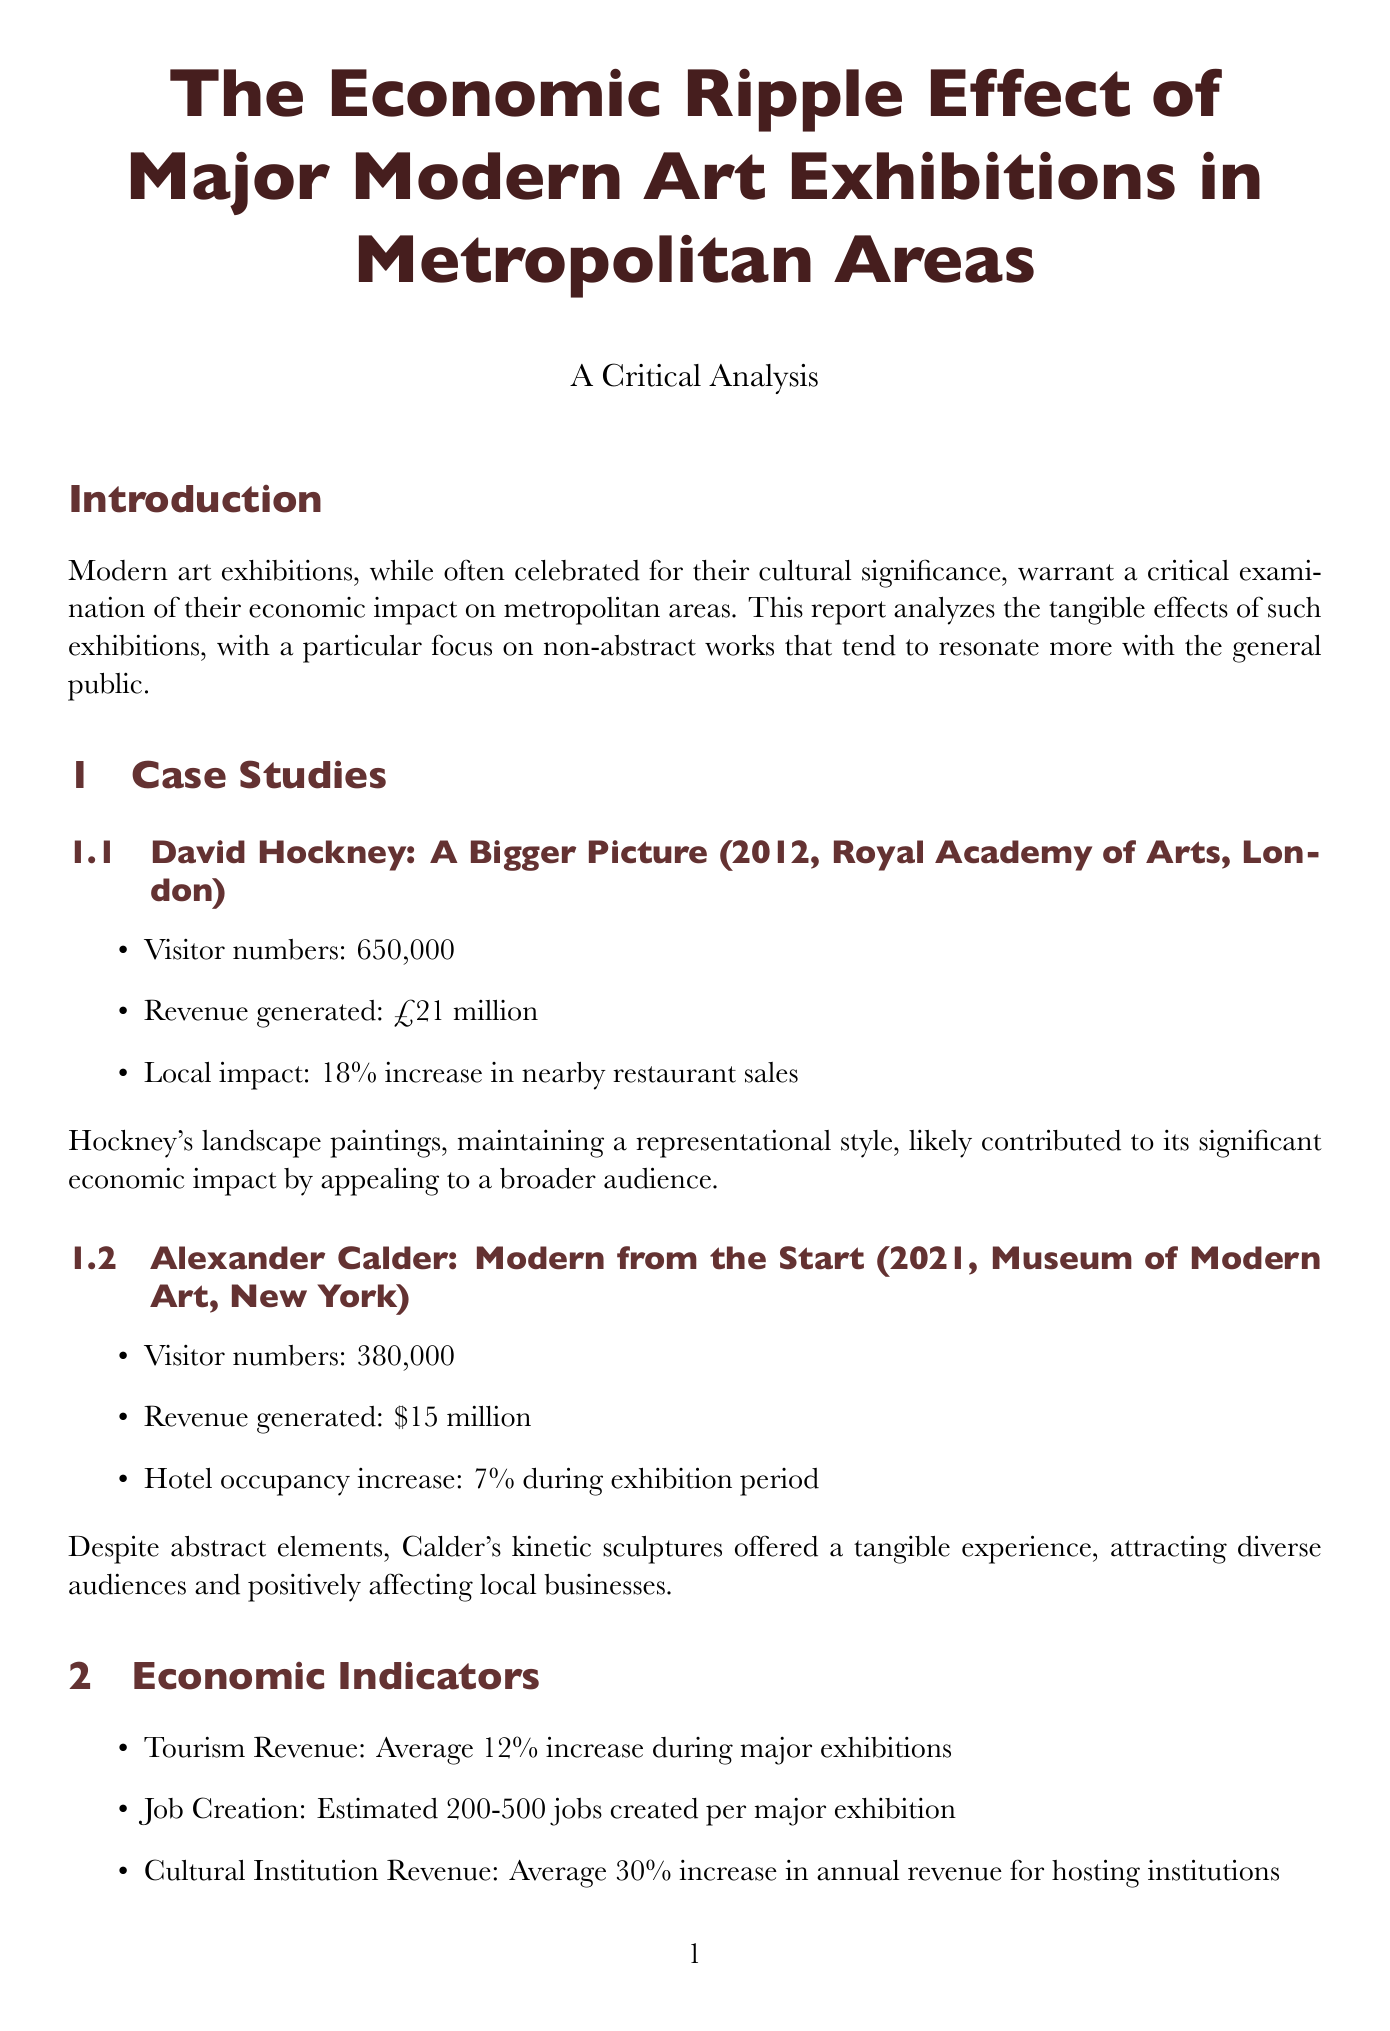what is the title of the report? The title is clearly stated at the beginning of the document.
Answer: The Economic Ripple Effect of Major Modern Art Exhibitions in Metropolitan Areas how many visitors attended the David Hockney exhibition? The document provides specific visitor numbers for this case study.
Answer: 650,000 what was the revenue generated by the Alexander Calder exhibition? The revenue amount for this exhibition is mentioned in its economic impact section.
Answer: $15 million what percentage increase in local business sales did the Hockney exhibition cause? The report notes the specific percentage increase in restaurant sales due to the exhibition.
Answer: 18% what is one major issue related to gentrification mentioned? The document discusses implications of economic boosts from art exhibitions.
Answer: Displacement of local residents how many jobs are estimated to be created per major exhibition? The document gives an estimate of job creation related to art exhibitions.
Answer: 200-500 what is a future trend mentioned for art exhibitions? The report highlights specific trends that may occur in future exhibitions.
Answer: Integration of technology what is emphasized in the conclusion about the types of artworks? The document stresses the importance of certain types of artworks for broader appeal.
Answer: Accessible, representational works 